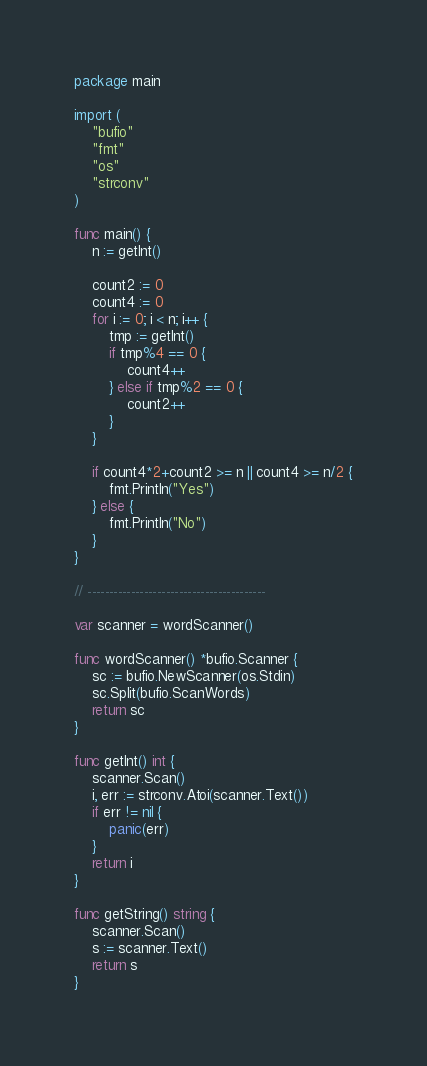<code> <loc_0><loc_0><loc_500><loc_500><_Go_>package main

import (
	"bufio"
	"fmt"
	"os"
	"strconv"
)

func main() {
	n := getInt()

	count2 := 0
	count4 := 0
	for i := 0; i < n; i++ {
		tmp := getInt()
		if tmp%4 == 0 {
			count4++
		} else if tmp%2 == 0 {
			count2++
		}
	}

	if count4*2+count2 >= n || count4 >= n/2 {
		fmt.Println("Yes")
	} else {
		fmt.Println("No")
	}
}

// -----------------------------------------

var scanner = wordScanner()

func wordScanner() *bufio.Scanner {
	sc := bufio.NewScanner(os.Stdin)
	sc.Split(bufio.ScanWords)
	return sc
}

func getInt() int {
	scanner.Scan()
	i, err := strconv.Atoi(scanner.Text())
	if err != nil {
		panic(err)
	}
	return i
}

func getString() string {
	scanner.Scan()
	s := scanner.Text()
	return s
}
</code> 